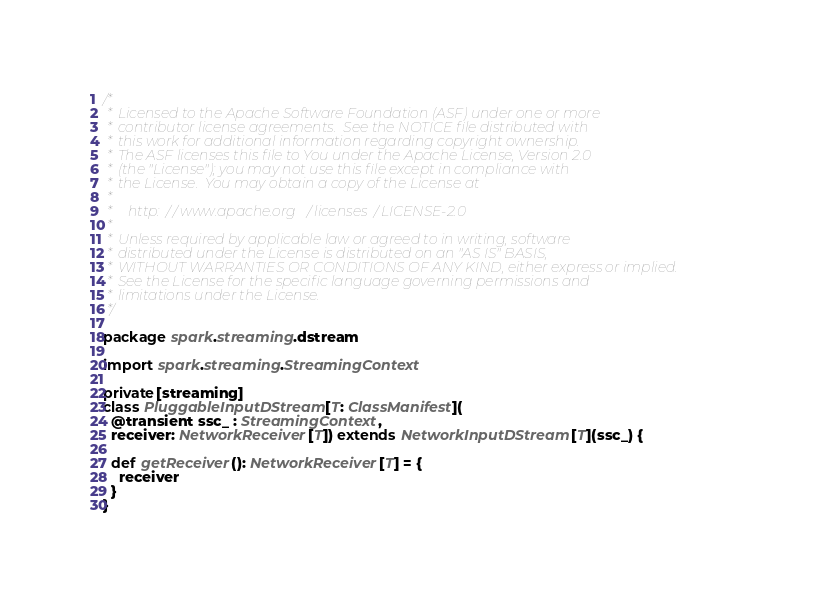Convert code to text. <code><loc_0><loc_0><loc_500><loc_500><_Scala_>/*
 * Licensed to the Apache Software Foundation (ASF) under one or more
 * contributor license agreements.  See the NOTICE file distributed with
 * this work for additional information regarding copyright ownership.
 * The ASF licenses this file to You under the Apache License, Version 2.0
 * (the "License"); you may not use this file except in compliance with
 * the License.  You may obtain a copy of the License at
 *
 *    http://www.apache.org/licenses/LICENSE-2.0
 *
 * Unless required by applicable law or agreed to in writing, software
 * distributed under the License is distributed on an "AS IS" BASIS,
 * WITHOUT WARRANTIES OR CONDITIONS OF ANY KIND, either express or implied.
 * See the License for the specific language governing permissions and
 * limitations under the License.
 */

package spark.streaming.dstream

import spark.streaming.StreamingContext

private[streaming]
class PluggableInputDStream[T: ClassManifest](
  @transient ssc_ : StreamingContext,
  receiver: NetworkReceiver[T]) extends NetworkInputDStream[T](ssc_) {

  def getReceiver(): NetworkReceiver[T] = {
    receiver
  }
}
</code> 